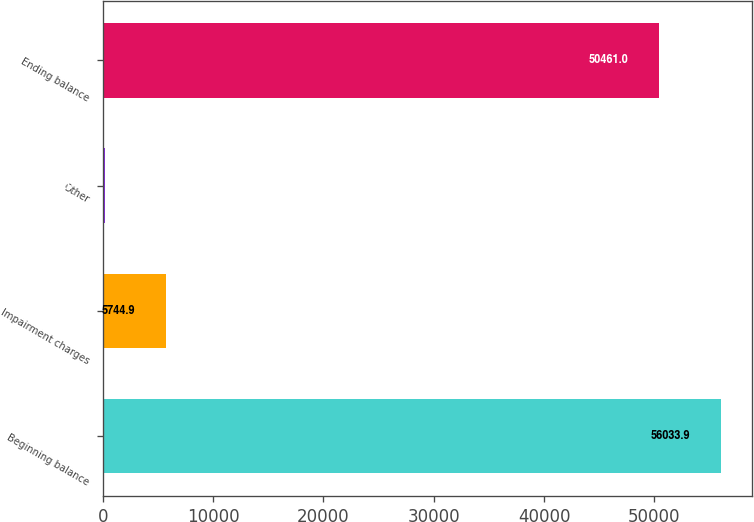Convert chart to OTSL. <chart><loc_0><loc_0><loc_500><loc_500><bar_chart><fcel>Beginning balance<fcel>Impairment charges<fcel>Other<fcel>Ending balance<nl><fcel>56033.9<fcel>5744.9<fcel>172<fcel>50461<nl></chart> 